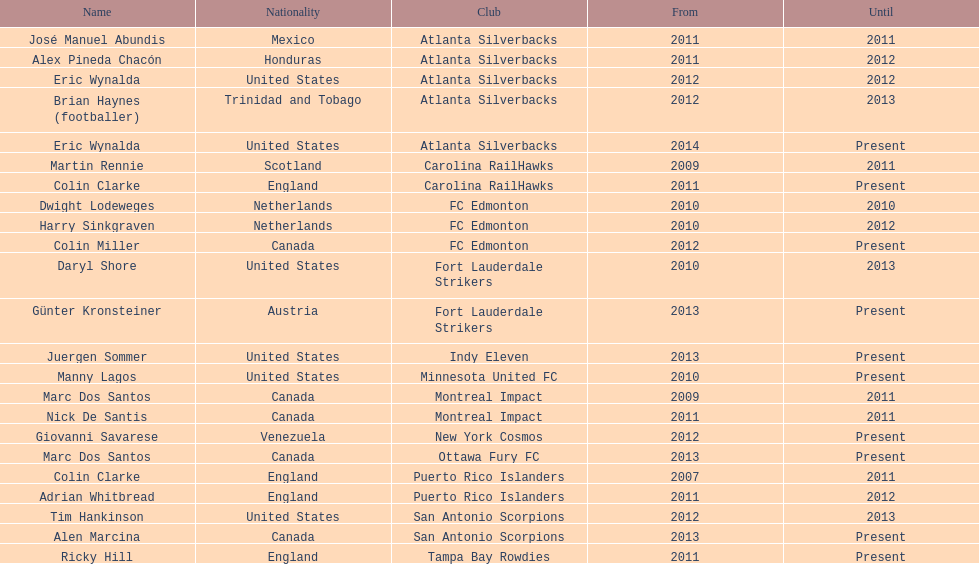How many coaches have coached from america? 6. 